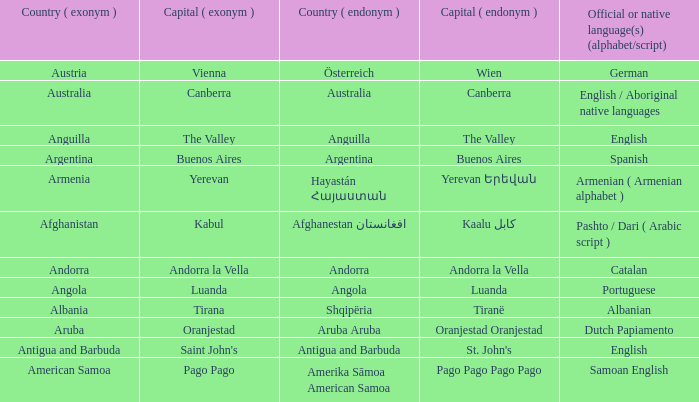How many capital cities does Australia have? 1.0. Could you parse the entire table? {'header': ['Country ( exonym )', 'Capital ( exonym )', 'Country ( endonym )', 'Capital ( endonym )', 'Official or native language(s) (alphabet/script)'], 'rows': [['Austria', 'Vienna', 'Österreich', 'Wien', 'German'], ['Australia', 'Canberra', 'Australia', 'Canberra', 'English / Aboriginal native languages'], ['Anguilla', 'The Valley', 'Anguilla', 'The Valley', 'English'], ['Argentina', 'Buenos Aires', 'Argentina', 'Buenos Aires', 'Spanish'], ['Armenia', 'Yerevan', 'Hayastán Հայաստան', 'Yerevan Երեվան', 'Armenian ( Armenian alphabet )'], ['Afghanistan', 'Kabul', 'Afghanestan افغانستان', 'Kaalu كابل', 'Pashto / Dari ( Arabic script )'], ['Andorra', 'Andorra la Vella', 'Andorra', 'Andorra la Vella', 'Catalan'], ['Angola', 'Luanda', 'Angola', 'Luanda', 'Portuguese'], ['Albania', 'Tirana', 'Shqipëria', 'Tiranë', 'Albanian'], ['Aruba', 'Oranjestad', 'Aruba Aruba', 'Oranjestad Oranjestad', 'Dutch Papiamento'], ['Antigua and Barbuda', "Saint John's", 'Antigua and Barbuda', "St. John's", 'English'], ['American Samoa', 'Pago Pago', 'Amerika Sāmoa American Samoa', 'Pago Pago Pago Pago', 'Samoan English']]} 